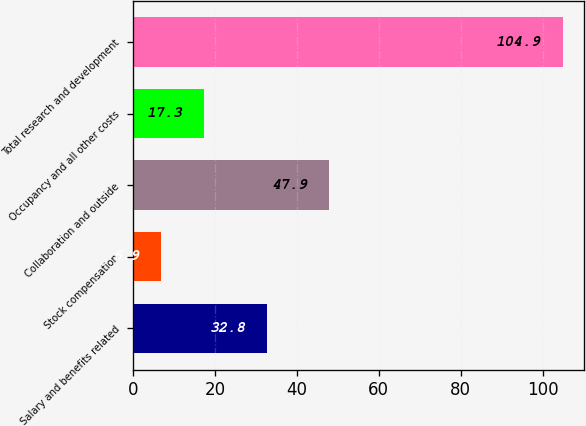Convert chart. <chart><loc_0><loc_0><loc_500><loc_500><bar_chart><fcel>Salary and benefits related<fcel>Stock compensation<fcel>Collaboration and outside<fcel>Occupancy and all other costs<fcel>Total research and development<nl><fcel>32.8<fcel>6.9<fcel>47.9<fcel>17.3<fcel>104.9<nl></chart> 